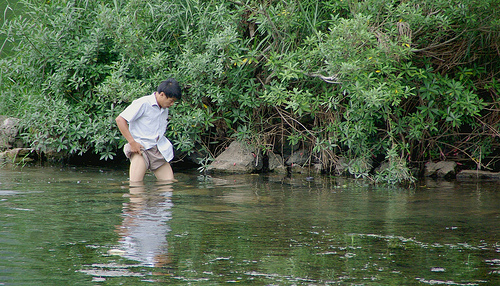<image>
Is the man in the water? Yes. The man is contained within or inside the water, showing a containment relationship. Is the man in front of the water? No. The man is not in front of the water. The spatial positioning shows a different relationship between these objects. Where is the man in relation to the water? Is it above the water? No. The man is not positioned above the water. The vertical arrangement shows a different relationship. 